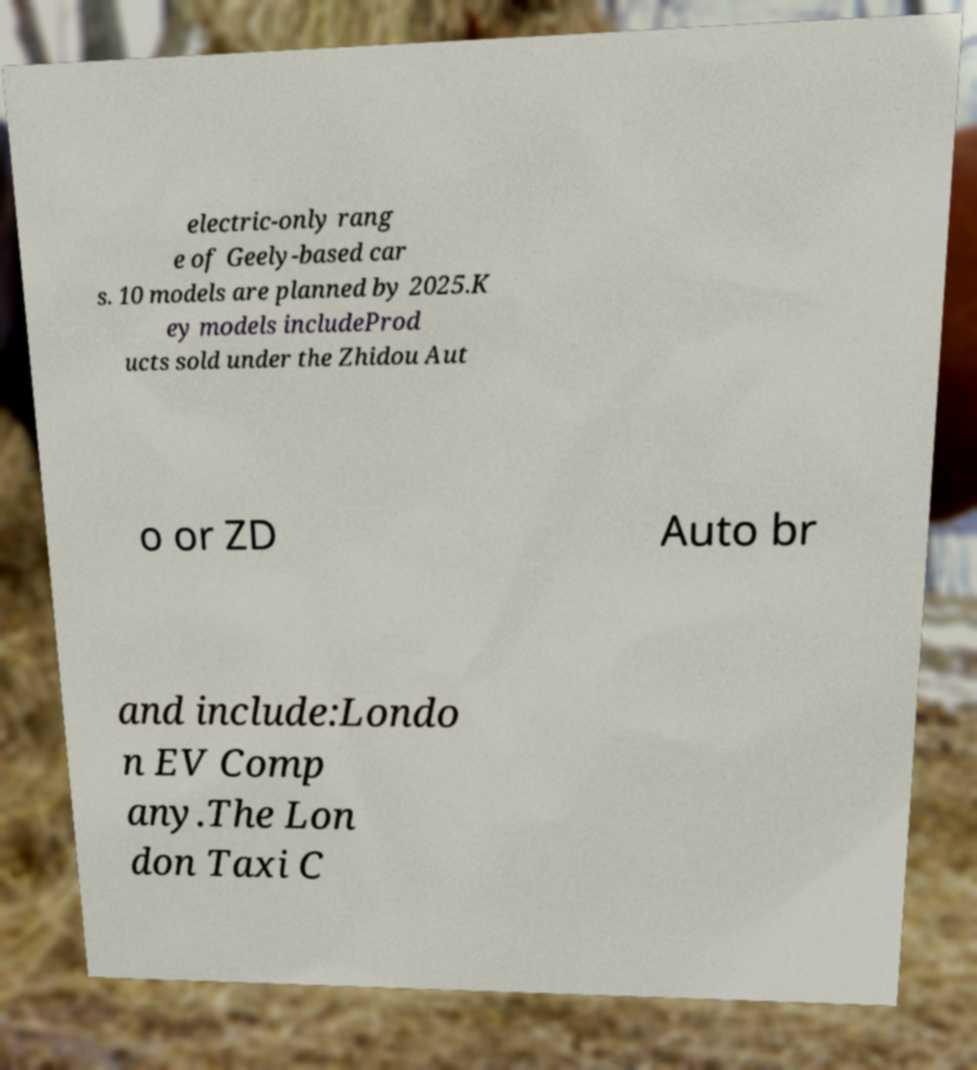What messages or text are displayed in this image? I need them in a readable, typed format. electric-only rang e of Geely-based car s. 10 models are planned by 2025.K ey models includeProd ucts sold under the Zhidou Aut o or ZD Auto br and include:Londo n EV Comp any.The Lon don Taxi C 